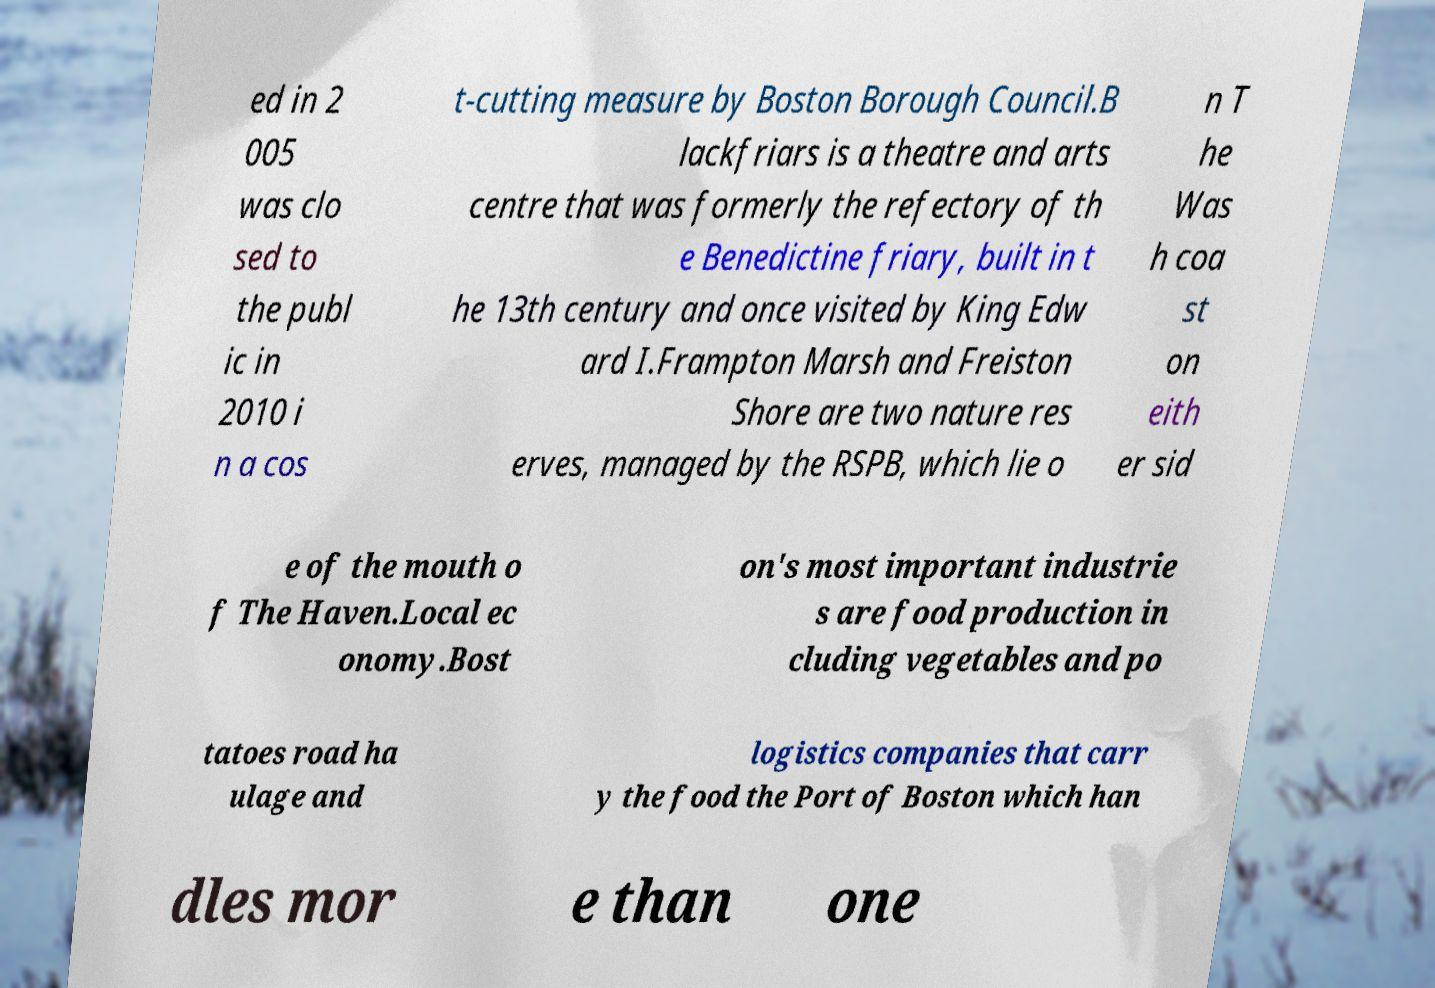Could you assist in decoding the text presented in this image and type it out clearly? ed in 2 005 was clo sed to the publ ic in 2010 i n a cos t-cutting measure by Boston Borough Council.B lackfriars is a theatre and arts centre that was formerly the refectory of th e Benedictine friary, built in t he 13th century and once visited by King Edw ard I.Frampton Marsh and Freiston Shore are two nature res erves, managed by the RSPB, which lie o n T he Was h coa st on eith er sid e of the mouth o f The Haven.Local ec onomy.Bost on's most important industrie s are food production in cluding vegetables and po tatoes road ha ulage and logistics companies that carr y the food the Port of Boston which han dles mor e than one 